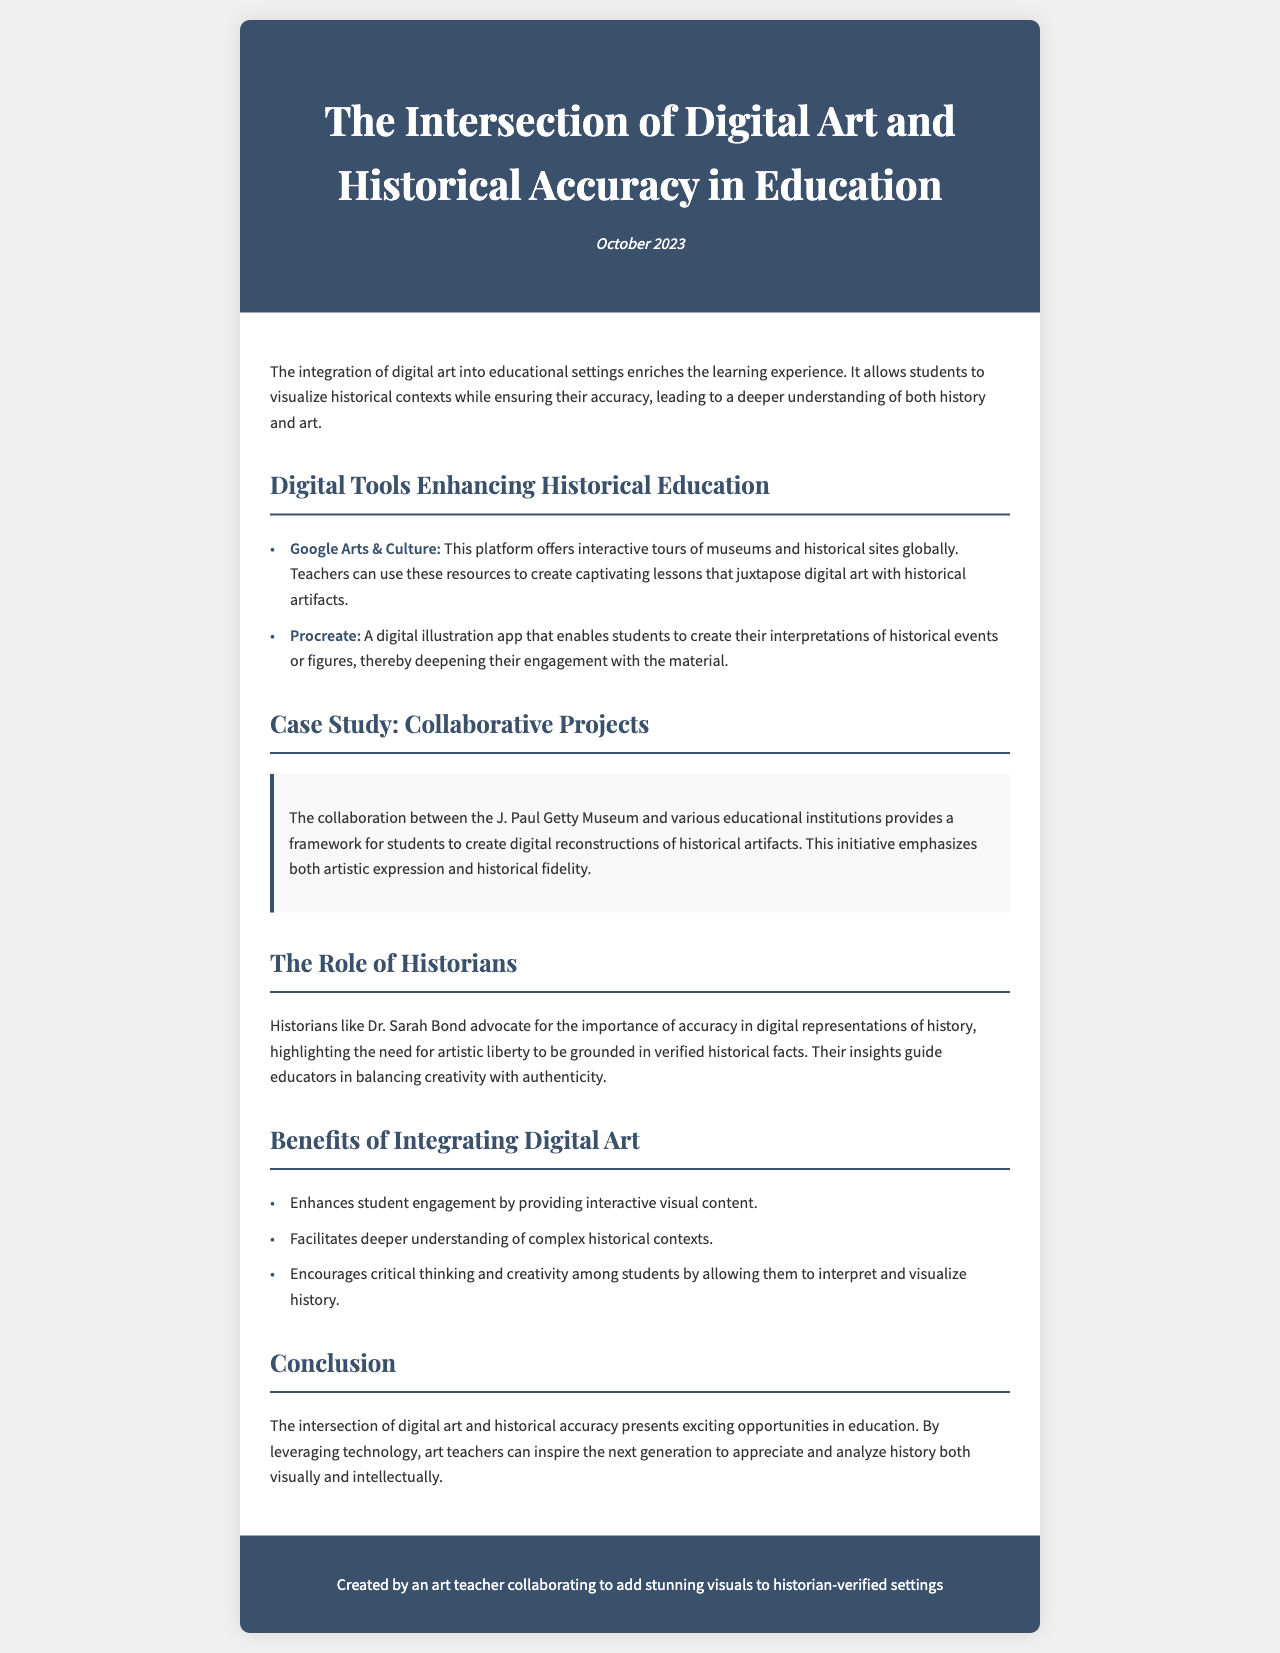What is the title of the newsletter? The title is stated in the header of the document.
Answer: The Intersection of Digital Art and Historical Accuracy in Education Who is quoted in the section about the role of historians? The document mentions a historian and their contributions to accuracy in digital representations.
Answer: Dr. Sarah Bond What are two digital tools mentioned that enhance historical education? The document lists specific tools in the section about digital tools for education.
Answer: Google Arts & Culture, Procreate What is one benefit of integrating digital art according to the document? This information is provided in the section outlining the benefits of digital art in education.
Answer: Enhances student engagement by providing interactive visual content What type of projects does the case study focus on? The document outlines the nature of collaborative efforts in the case study section.
Answer: Collaborative Projects How does the document conclude the discussion on digital art and historical accuracy? The conclusion summarizes the overall implications discussed throughout the newsletter.
Answer: Presents exciting opportunities in education 